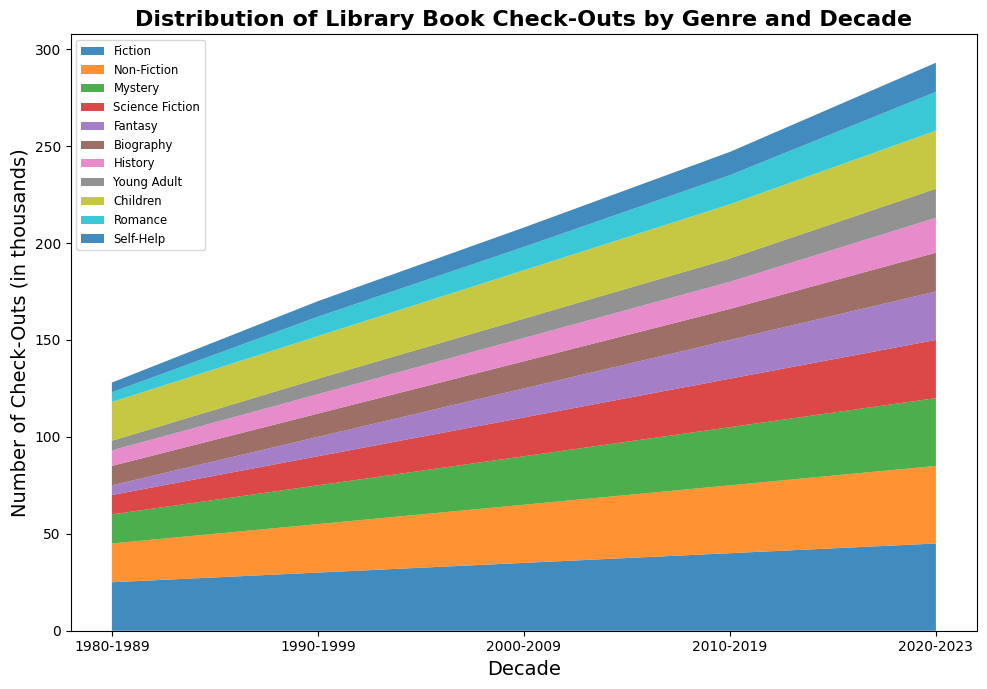What genre had the highest increase in check-outs from 1980-1989 to 2020-2023? To find the genre with the highest increase, subtract the number of check-outs in 1980-1989 from the number of check-outs in 2020-2023 for each genre and compare the results. Fiction increased from 25 to 45, Non-Fiction from 20 to 40, Mystery from 15 to 35, Science Fiction from 10 to 30, Fantasy from 5 to 25, Biography from 10 to 20, History from 8 to 18, Young Adult from 5 to 15, Children from 20 to 30, Romance from 5 to 20, Self-Help from 5 to 15. The biggest increase is Fiction (45 - 25 = 20).
Answer: Fiction Which decade saw the highest number of check-outs for Science Fiction books? Examine the height of the area corresponding to Science Fiction in each decade. The number of check-outs for Science Fiction increased over the decades: 10 in the 1980s, 15 in the 1990s, 20 in the 2000s, 25 in the 2010s, 30 in the 2020s. The decade with the highest number is 2020-2023.
Answer: 2020-2023 How many total check-outs were there for Mystery and Romance genres combined in the 2010-2019 decade? Add the number of check-outs for Mystery and Romance in the 2010-2019 decade. Mystery had 30, and Romance had 15. So, the total is 30 + 15.
Answer: 45 Which genre remained consistently lower than Children's books in check-outs across all decades? Compare the height of the areas corresponding to Children's books with other genres across all decades. Children's books have higher check-outs than Romance, Fantasy, Young Adult, Biography, Science Fiction, and more. Fantasy, for example, remains consistently lower in check-outs.
Answer: Fantasy What is the average number of check-outs for Non-Fiction books from 1980-2023? Add the check-outs for Non-Fiction books across all decades and divide by the number of decades. Sum of check-outs: 20 + 25 + 30 + 35 + 40 = 150. There are 5 decades, so the average is 150 / 5.
Answer: 30 Which decade shows the largest overall increase in check-outs for all genres combined? Calculate the total check-outs for each decade by summing the check-outs for all genres. Compare the totals to identify the largest overall increase. For example:
1980s: 128
1990s: 175
2000s: 226
2010s: 287
2020s: 343
The largest increase occurs between the 2010s and 2020s (343 - 287 = 56).
Answer: 2020-2023 Which genre had the least number of check-outs in the 1990-1999 decade? Look for the shortest area segment corresponding to the 1990-1999 decade. The height of the segments representing Romance (10) and Fantasy (10) are the smallest. Comparing further back, Romance only starts from 1980, and Fantasy from 1990.
Answer: Romance What's the difference in check-outs between Fiction and Non-Fiction genres in the 2000-2009 decade? Subtract the number of check-outs for Non-Fiction from the number of check-outs for Fiction in the 2000-2009 decade. Fiction had 35, and Non-Fiction had 30. So, the difference is 35 - 30.
Answer: 5 